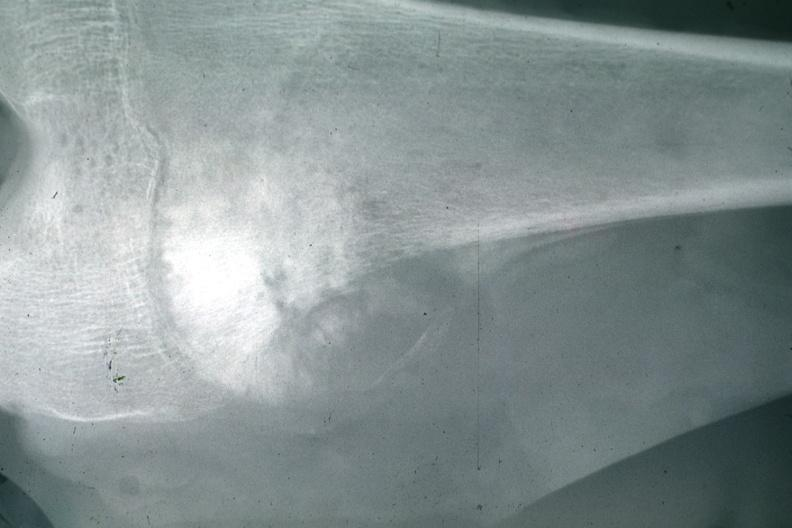what is present?
Answer the question using a single word or phrase. Joints 